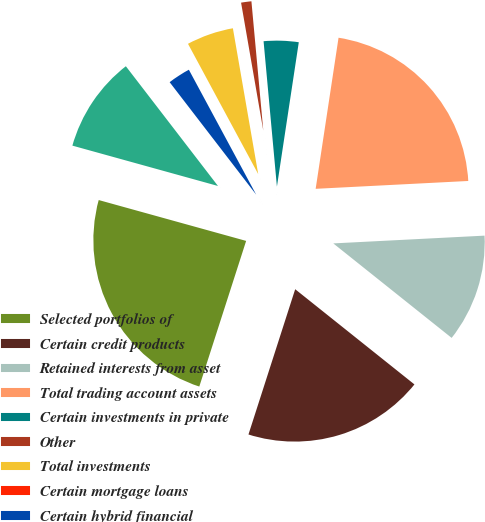<chart> <loc_0><loc_0><loc_500><loc_500><pie_chart><fcel>Selected portfolios of<fcel>Certain credit products<fcel>Retained interests from asset<fcel>Total trading account assets<fcel>Certain investments in private<fcel>Other<fcel>Total investments<fcel>Certain mortgage loans<fcel>Certain hybrid financial<fcel>Total loans<nl><fcel>24.35%<fcel>19.23%<fcel>11.54%<fcel>21.79%<fcel>3.85%<fcel>1.28%<fcel>5.13%<fcel>0.0%<fcel>2.57%<fcel>10.26%<nl></chart> 